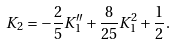Convert formula to latex. <formula><loc_0><loc_0><loc_500><loc_500>K _ { 2 } = - \frac { 2 } { 5 } K _ { 1 } ^ { \prime \prime } + \frac { 8 } { 2 5 } K _ { 1 } ^ { 2 } + \frac { 1 } { 2 } .</formula> 